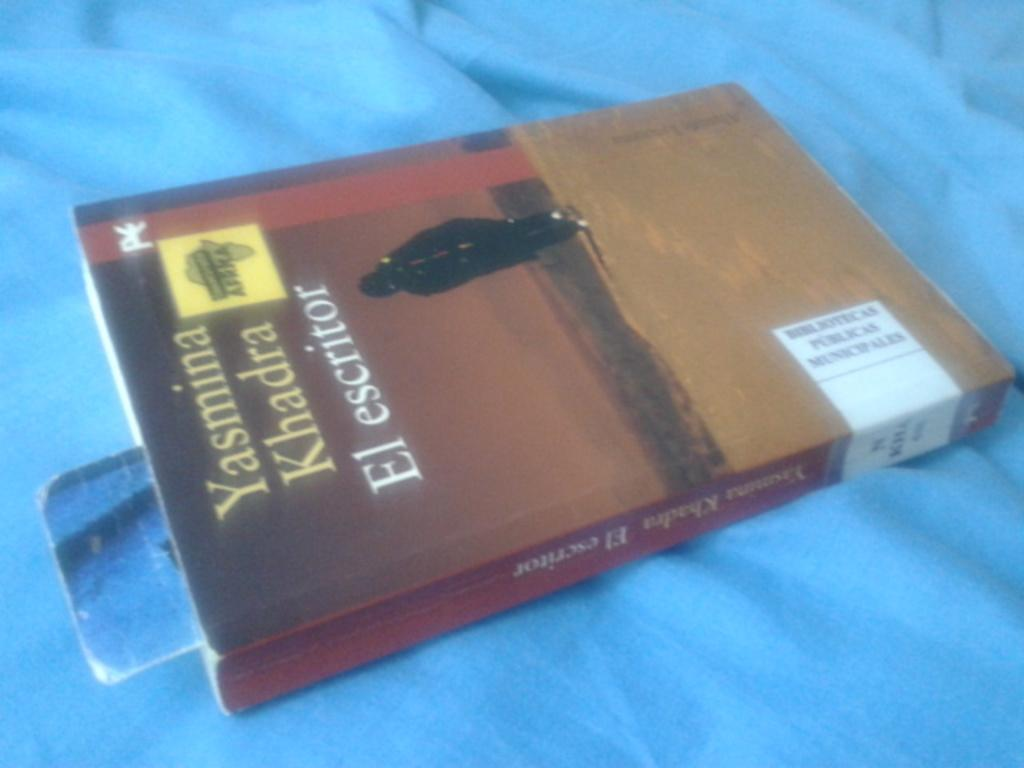What object can be seen in the image? There is a book in the image. What feature is present on the book? The book has a cover. What information is displayed on the book cover? The name on the book cover is Yasima Khadra el escritoire. On what is the book placed? The book is placed on a blue cover cloth. What type of pet is visible in the image? There is no pet present in the image. How many parcels are being delivered in the image? There is no parcel delivery depicted in the image. 